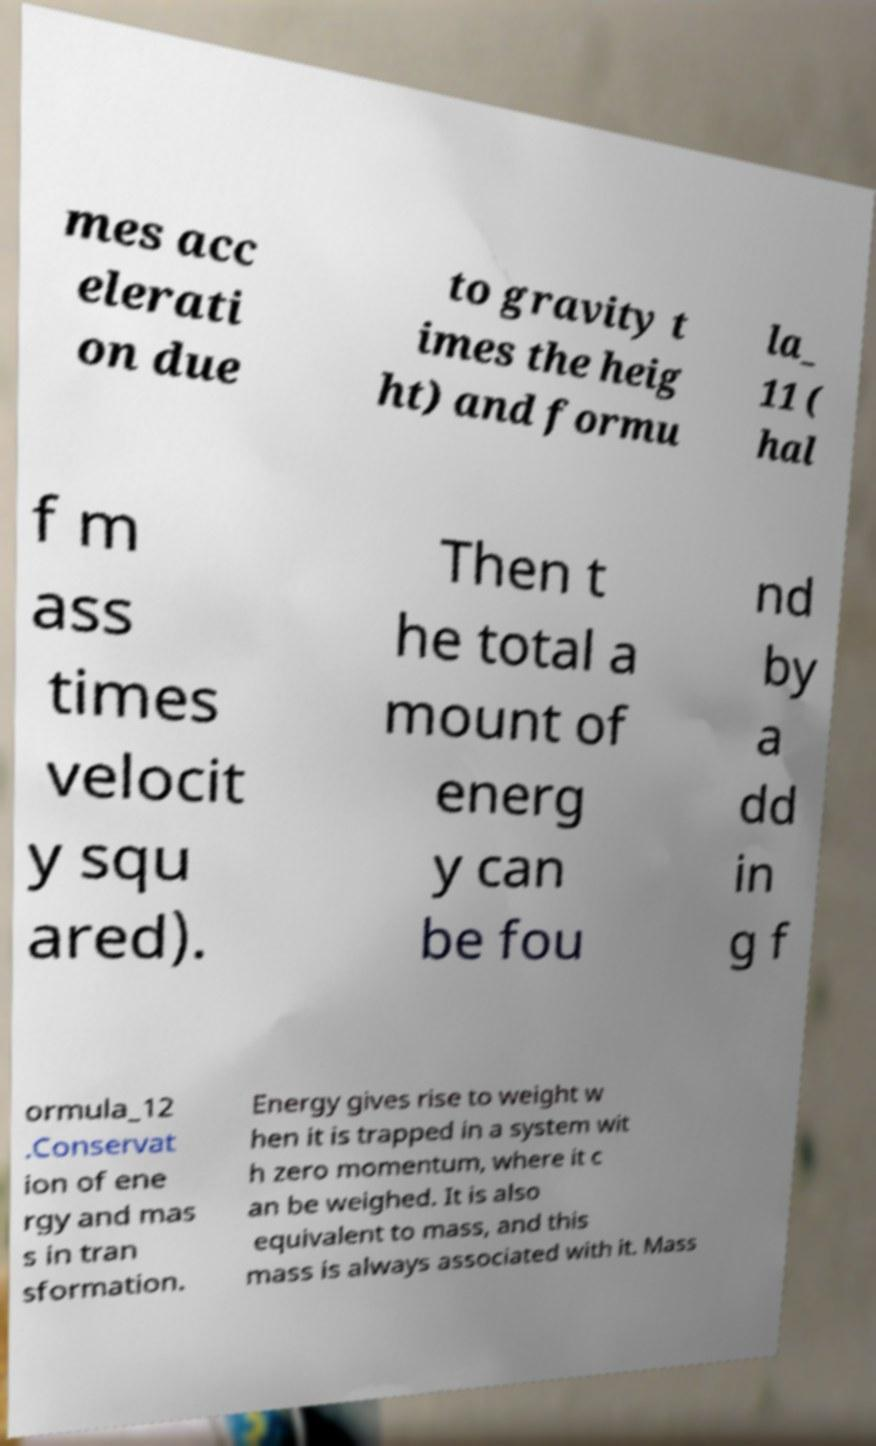There's text embedded in this image that I need extracted. Can you transcribe it verbatim? mes acc elerati on due to gravity t imes the heig ht) and formu la_ 11 ( hal f m ass times velocit y squ ared). Then t he total a mount of energ y can be fou nd by a dd in g f ormula_12 .Conservat ion of ene rgy and mas s in tran sformation. Energy gives rise to weight w hen it is trapped in a system wit h zero momentum, where it c an be weighed. It is also equivalent to mass, and this mass is always associated with it. Mass 